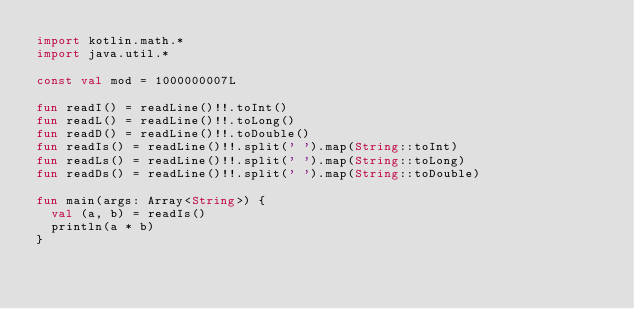<code> <loc_0><loc_0><loc_500><loc_500><_Kotlin_>import kotlin.math.*
import java.util.*

const val mod = 1000000007L

fun readI() = readLine()!!.toInt()
fun readL() = readLine()!!.toLong()
fun readD() = readLine()!!.toDouble()
fun readIs() = readLine()!!.split(' ').map(String::toInt)
fun readLs() = readLine()!!.split(' ').map(String::toLong)
fun readDs() = readLine()!!.split(' ').map(String::toDouble)

fun main(args: Array<String>) {
  val (a, b) = readIs()
  println(a * b)
}
</code> 